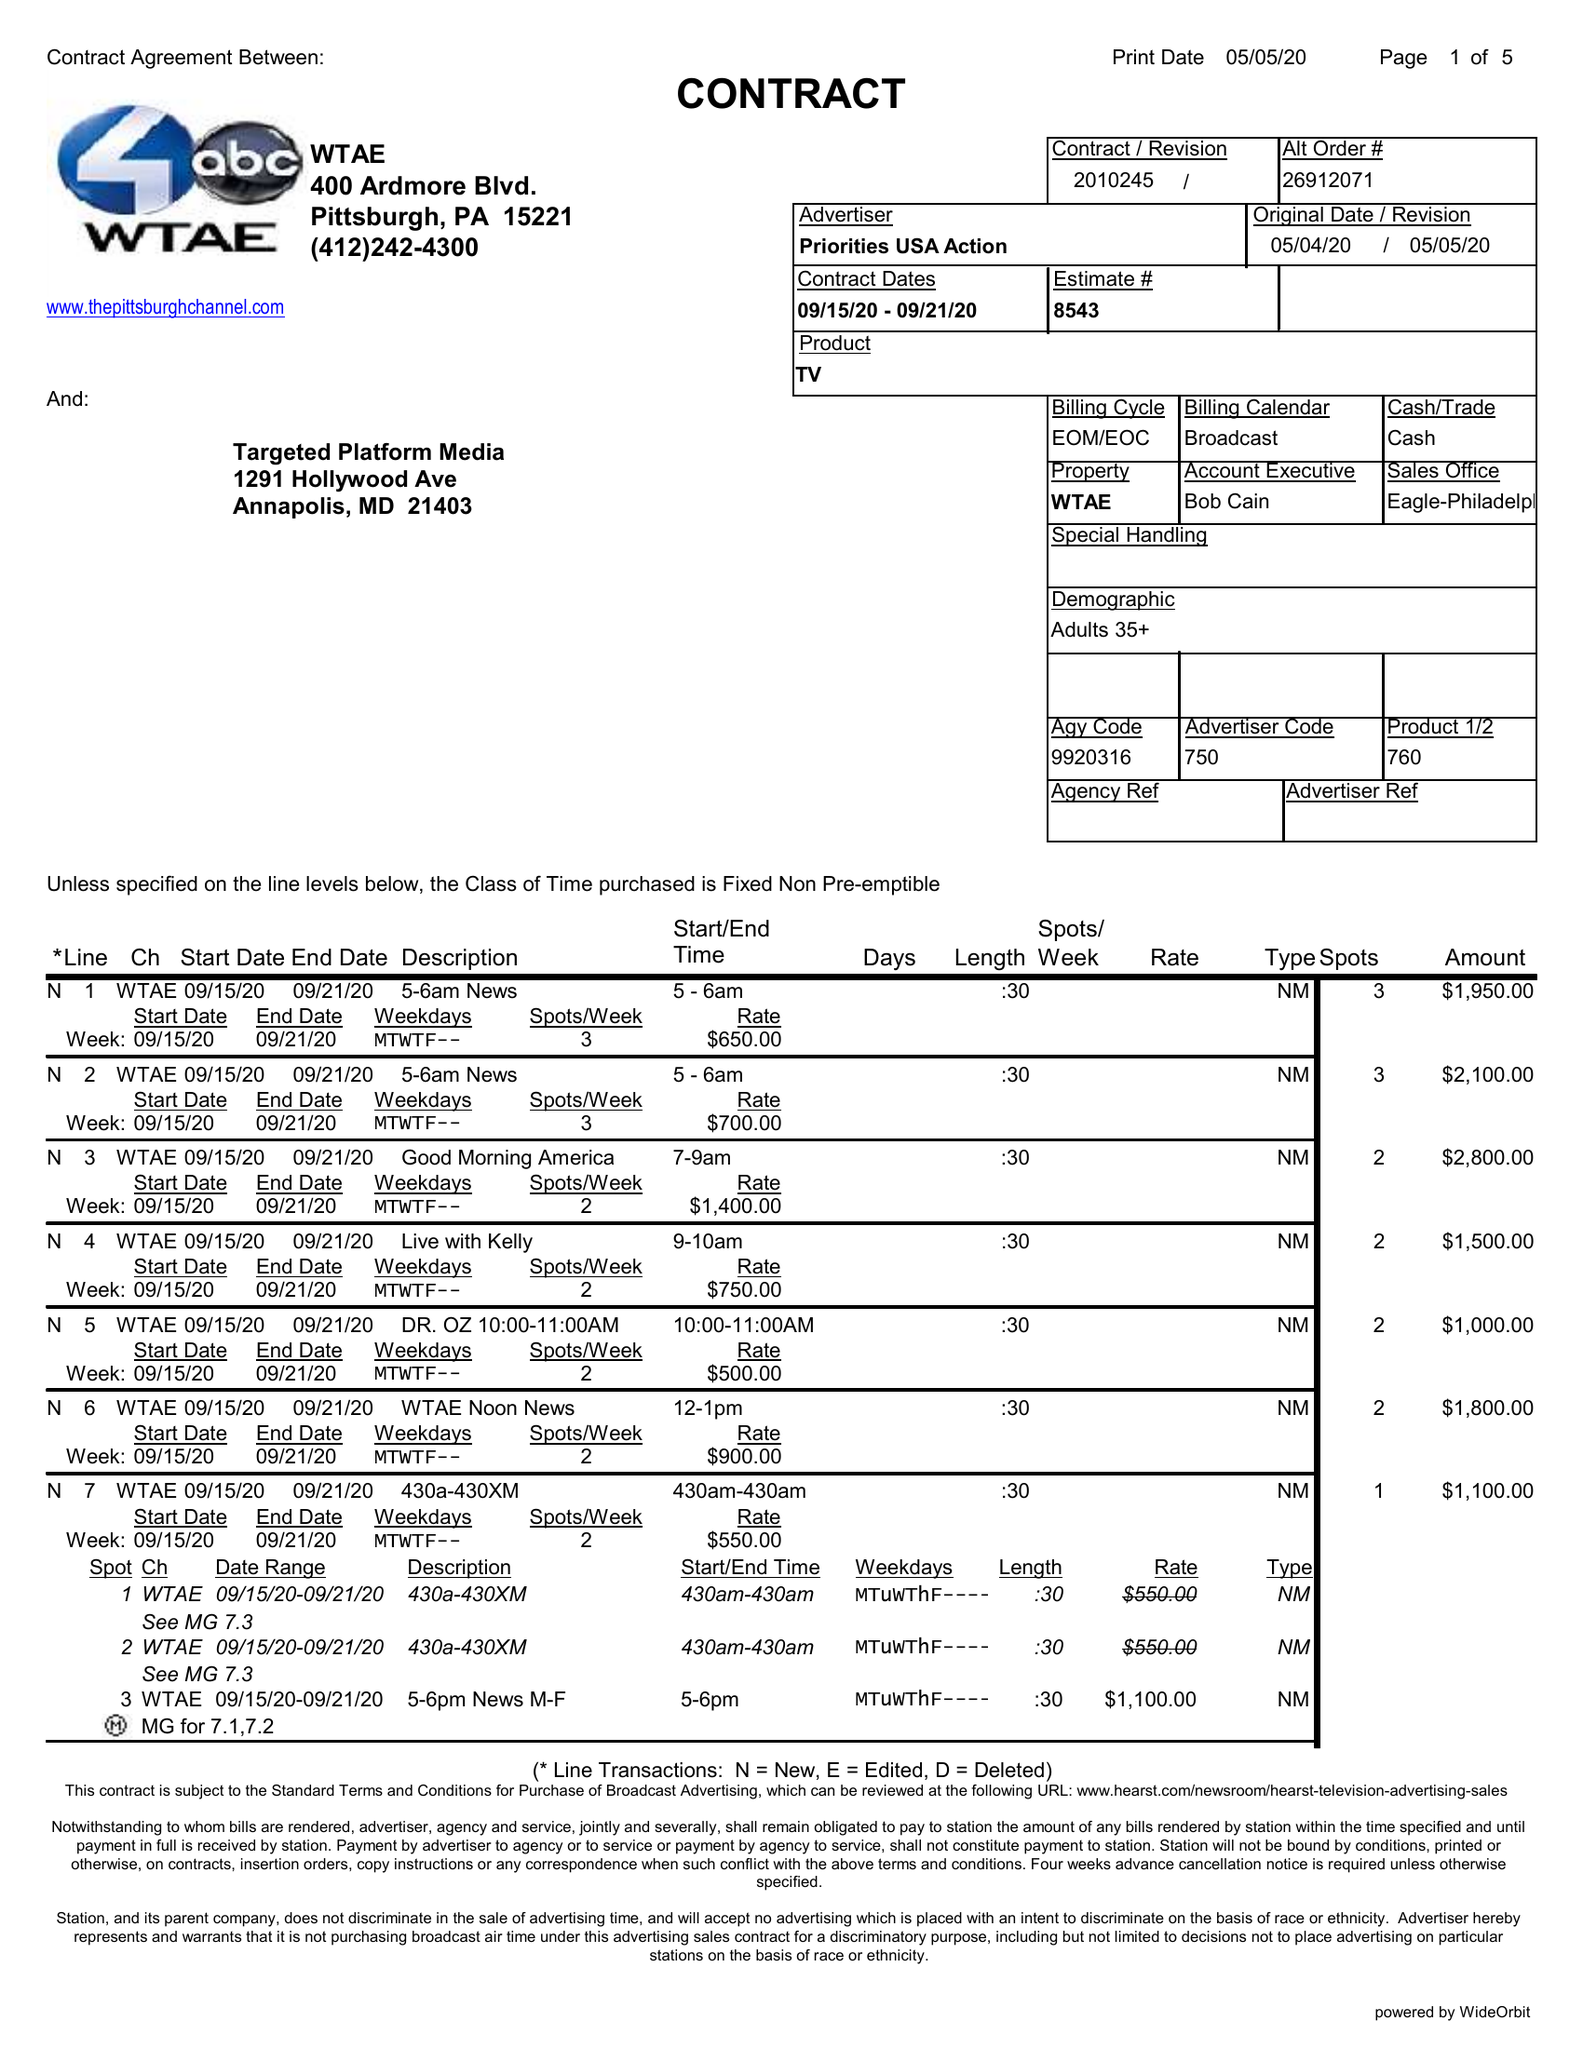What is the value for the contract_num?
Answer the question using a single word or phrase. 2010245 